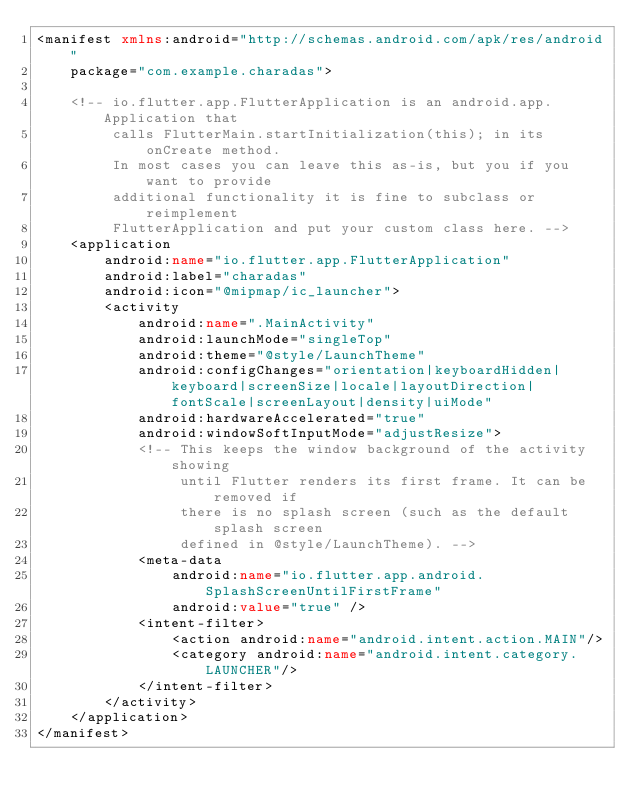<code> <loc_0><loc_0><loc_500><loc_500><_XML_><manifest xmlns:android="http://schemas.android.com/apk/res/android"
    package="com.example.charadas">

    <!-- io.flutter.app.FlutterApplication is an android.app.Application that
         calls FlutterMain.startInitialization(this); in its onCreate method.
         In most cases you can leave this as-is, but you if you want to provide
         additional functionality it is fine to subclass or reimplement
         FlutterApplication and put your custom class here. -->
    <application
        android:name="io.flutter.app.FlutterApplication"
        android:label="charadas"
        android:icon="@mipmap/ic_launcher">
        <activity
            android:name=".MainActivity"
            android:launchMode="singleTop"
            android:theme="@style/LaunchTheme"
            android:configChanges="orientation|keyboardHidden|keyboard|screenSize|locale|layoutDirection|fontScale|screenLayout|density|uiMode"
            android:hardwareAccelerated="true"
            android:windowSoftInputMode="adjustResize">
            <!-- This keeps the window background of the activity showing
                 until Flutter renders its first frame. It can be removed if
                 there is no splash screen (such as the default splash screen
                 defined in @style/LaunchTheme). -->
            <meta-data
                android:name="io.flutter.app.android.SplashScreenUntilFirstFrame"
                android:value="true" />
            <intent-filter>
                <action android:name="android.intent.action.MAIN"/>
                <category android:name="android.intent.category.LAUNCHER"/>
            </intent-filter>
        </activity>
    </application>
</manifest>
</code> 